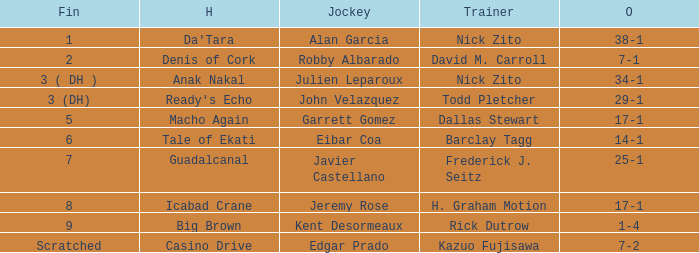Who is the Jockey for guadalcanal? Javier Castellano. 